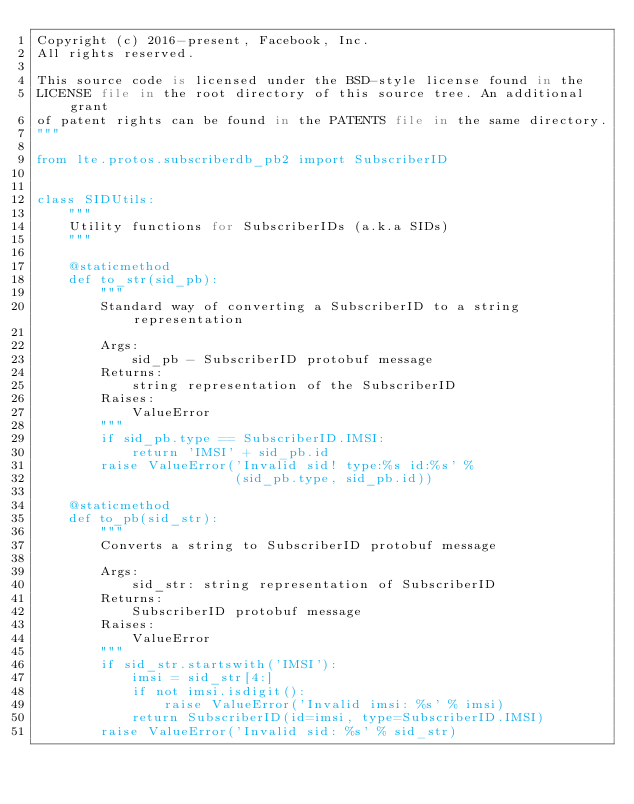<code> <loc_0><loc_0><loc_500><loc_500><_Python_>Copyright (c) 2016-present, Facebook, Inc.
All rights reserved.

This source code is licensed under the BSD-style license found in the
LICENSE file in the root directory of this source tree. An additional grant
of patent rights can be found in the PATENTS file in the same directory.
"""

from lte.protos.subscriberdb_pb2 import SubscriberID


class SIDUtils:
    """
    Utility functions for SubscriberIDs (a.k.a SIDs)
    """

    @staticmethod
    def to_str(sid_pb):
        """
        Standard way of converting a SubscriberID to a string representation

        Args:
            sid_pb - SubscriberID protobuf message
        Returns:
            string representation of the SubscriberID
        Raises:
            ValueError
        """
        if sid_pb.type == SubscriberID.IMSI:
            return 'IMSI' + sid_pb.id
        raise ValueError('Invalid sid! type:%s id:%s' %
                         (sid_pb.type, sid_pb.id))

    @staticmethod
    def to_pb(sid_str):
        """
        Converts a string to SubscriberID protobuf message

        Args:
            sid_str: string representation of SubscriberID
        Returns:
            SubscriberID protobuf message
        Raises:
            ValueError
        """
        if sid_str.startswith('IMSI'):
            imsi = sid_str[4:]
            if not imsi.isdigit():
                raise ValueError('Invalid imsi: %s' % imsi)
            return SubscriberID(id=imsi, type=SubscriberID.IMSI)
        raise ValueError('Invalid sid: %s' % sid_str)
</code> 